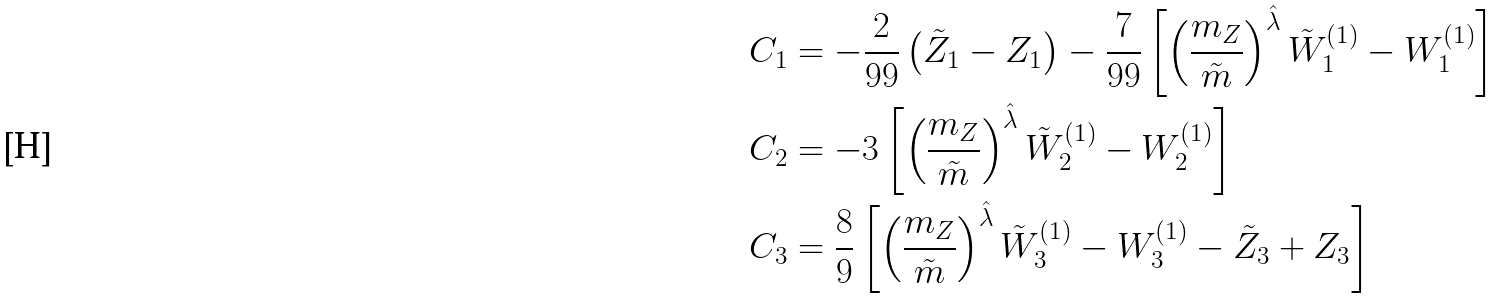Convert formula to latex. <formula><loc_0><loc_0><loc_500><loc_500>C _ { 1 } & = - \frac { 2 } { 9 9 } \left ( \tilde { Z } _ { 1 } - Z _ { 1 } \right ) - \frac { 7 } { 9 9 } \left [ \left ( \frac { m _ { Z } } { \tilde { m } } \right ) ^ { \hat { \lambda } } \tilde { W } ^ { ( 1 ) } _ { 1 } - W ^ { ( 1 ) } _ { 1 } \right ] \\ C _ { 2 } & = - 3 \left [ \left ( \frac { m _ { Z } } { \tilde { m } } \right ) ^ { \hat { \lambda } } \tilde { W } ^ { ( 1 ) } _ { 2 } - W ^ { ( 1 ) } _ { 2 } \right ] \\ C _ { 3 } & = \frac { 8 } { 9 } \left [ \left ( \frac { m _ { Z } } { \tilde { m } } \right ) ^ { \hat { \lambda } } \tilde { W } ^ { ( 1 ) } _ { 3 } - W ^ { ( 1 ) } _ { 3 } - \tilde { Z } _ { 3 } + Z _ { 3 } \right ]</formula> 